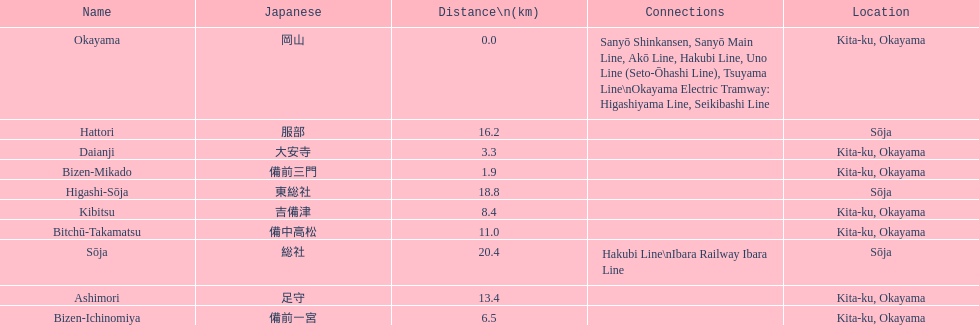Which has a distance less than 3.0 kilometers? Bizen-Mikado. Would you be able to parse every entry in this table? {'header': ['Name', 'Japanese', 'Distance\\n(km)', 'Connections', 'Location'], 'rows': [['Okayama', '岡山', '0.0', 'Sanyō Shinkansen, Sanyō Main Line, Akō Line, Hakubi Line, Uno Line (Seto-Ōhashi Line), Tsuyama Line\\nOkayama Electric Tramway: Higashiyama Line, Seikibashi Line', 'Kita-ku, Okayama'], ['Hattori', '服部', '16.2', '', 'Sōja'], ['Daianji', '大安寺', '3.3', '', 'Kita-ku, Okayama'], ['Bizen-Mikado', '備前三門', '1.9', '', 'Kita-ku, Okayama'], ['Higashi-Sōja', '東総社', '18.8', '', 'Sōja'], ['Kibitsu', '吉備津', '8.4', '', 'Kita-ku, Okayama'], ['Bitchū-Takamatsu', '備中高松', '11.0', '', 'Kita-ku, Okayama'], ['Sōja', '総社', '20.4', 'Hakubi Line\\nIbara Railway Ibara Line', 'Sōja'], ['Ashimori', '足守', '13.4', '', 'Kita-ku, Okayama'], ['Bizen-Ichinomiya', '備前一宮', '6.5', '', 'Kita-ku, Okayama']]} 